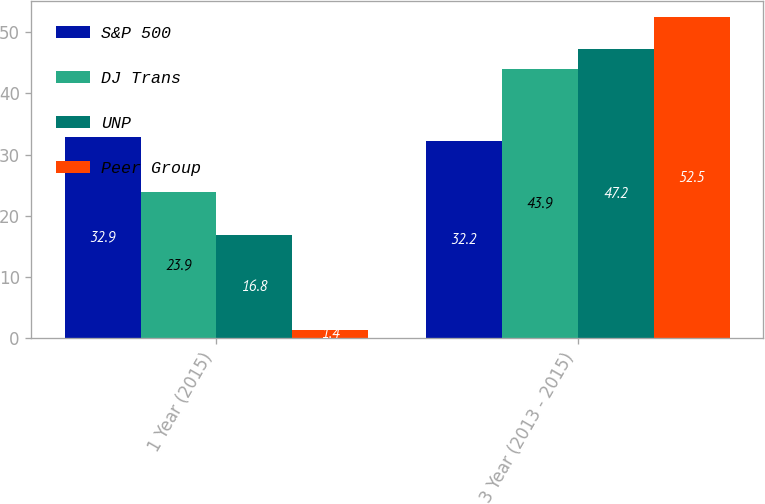Convert chart. <chart><loc_0><loc_0><loc_500><loc_500><stacked_bar_chart><ecel><fcel>1 Year (2015)<fcel>3 Year (2013 - 2015)<nl><fcel>S&P 500<fcel>32.9<fcel>32.2<nl><fcel>DJ Trans<fcel>23.9<fcel>43.9<nl><fcel>UNP<fcel>16.8<fcel>47.2<nl><fcel>Peer Group<fcel>1.4<fcel>52.5<nl></chart> 